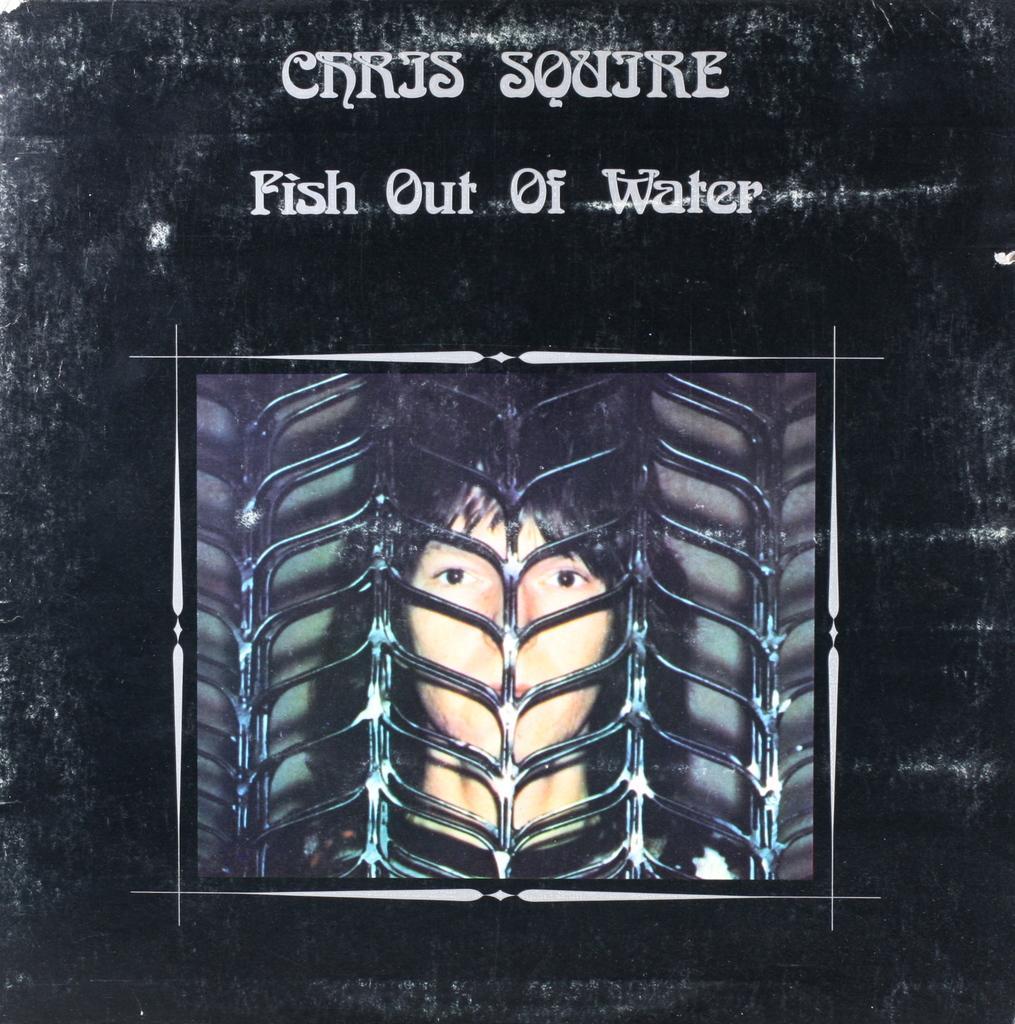Please provide a concise description of this image. In this image we can see a poster with a text. Also there is an image of a person behind the grille. 